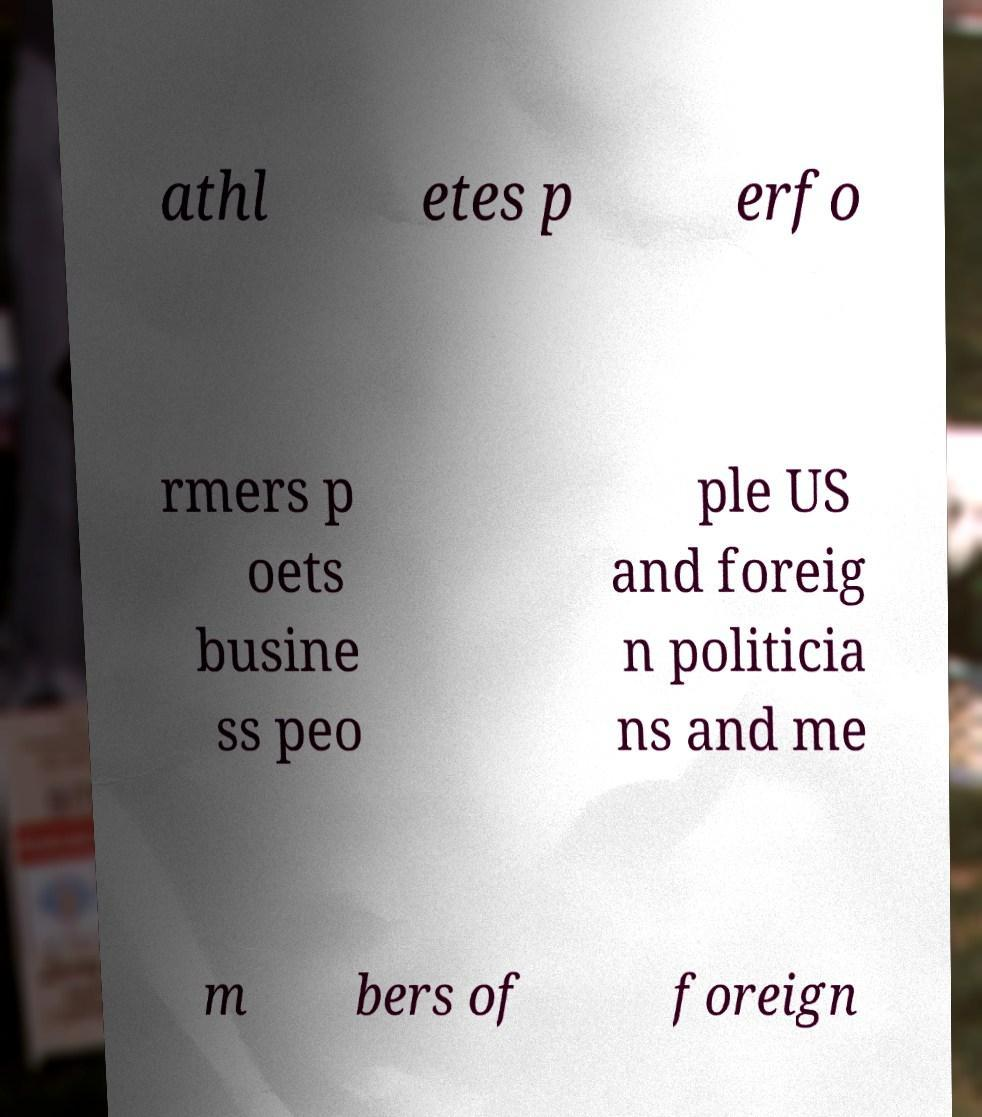Please identify and transcribe the text found in this image. athl etes p erfo rmers p oets busine ss peo ple US and foreig n politicia ns and me m bers of foreign 